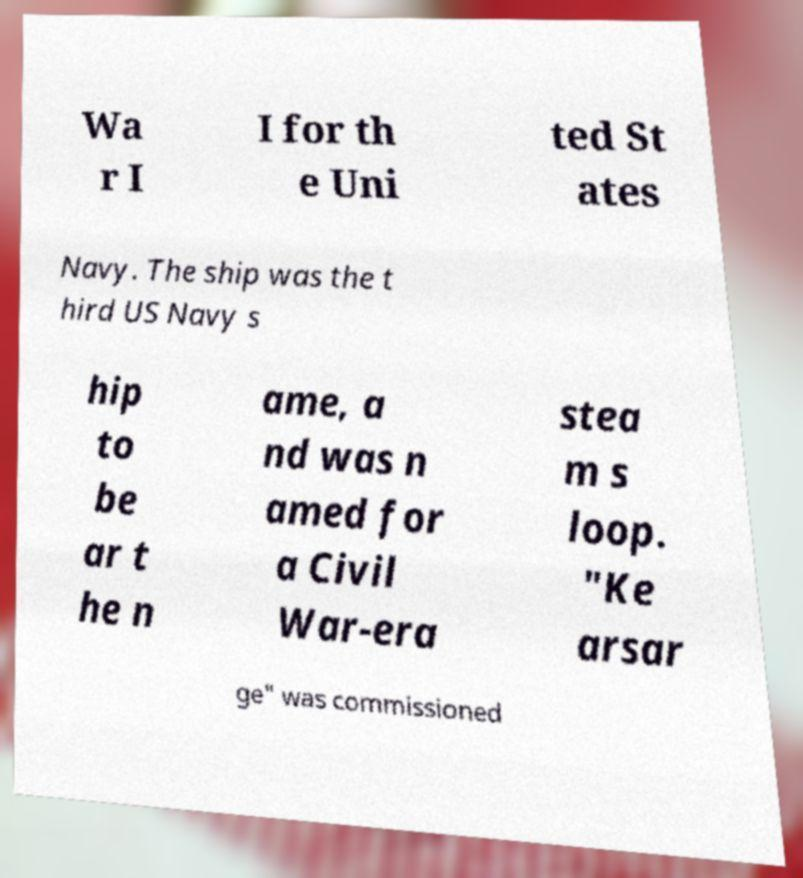Please identify and transcribe the text found in this image. Wa r I I for th e Uni ted St ates Navy. The ship was the t hird US Navy s hip to be ar t he n ame, a nd was n amed for a Civil War-era stea m s loop. "Ke arsar ge" was commissioned 